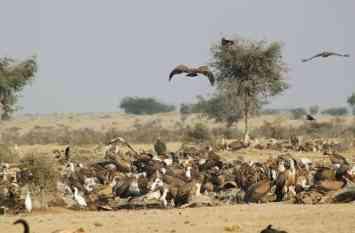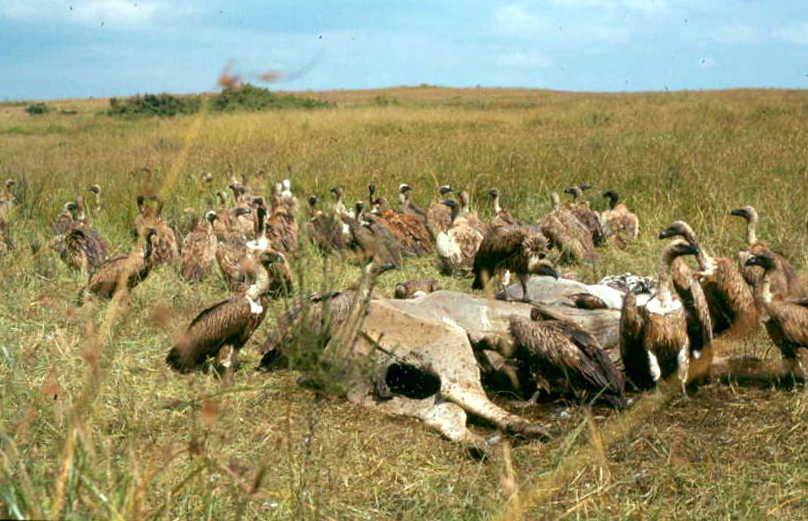The first image is the image on the left, the second image is the image on the right. Given the left and right images, does the statement "In one image, you can see a line of hooved-type animals in the background behind the vultures." hold true? Answer yes or no. No. The first image is the image on the left, the second image is the image on the right. Evaluate the accuracy of this statement regarding the images: "There are two flying birds in the image on the left.". Is it true? Answer yes or no. Yes. 